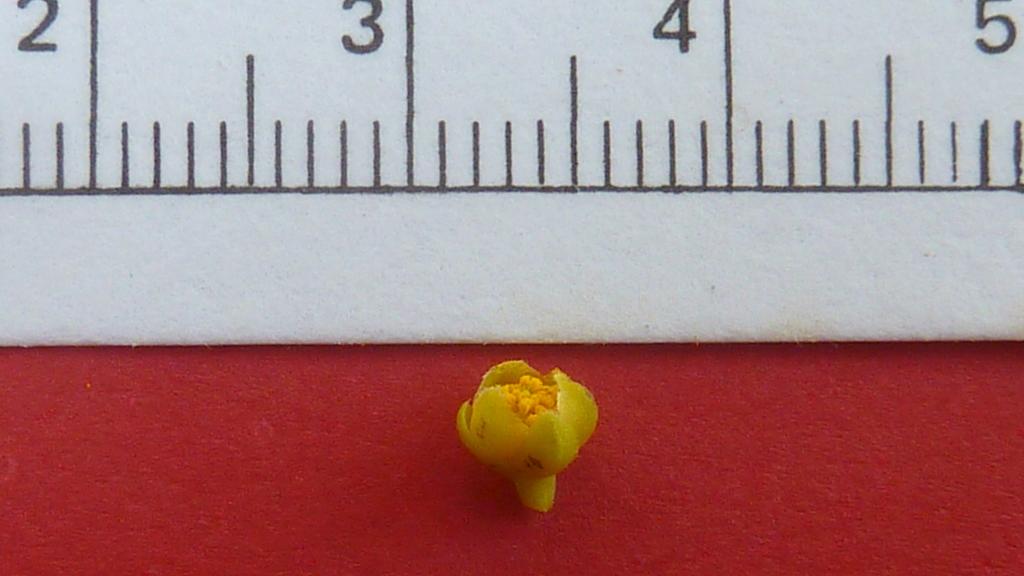What number is in the top left?
Make the answer very short. 2. 